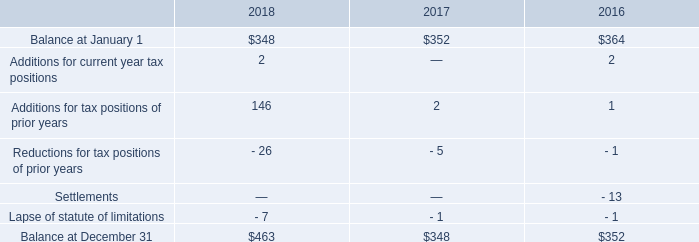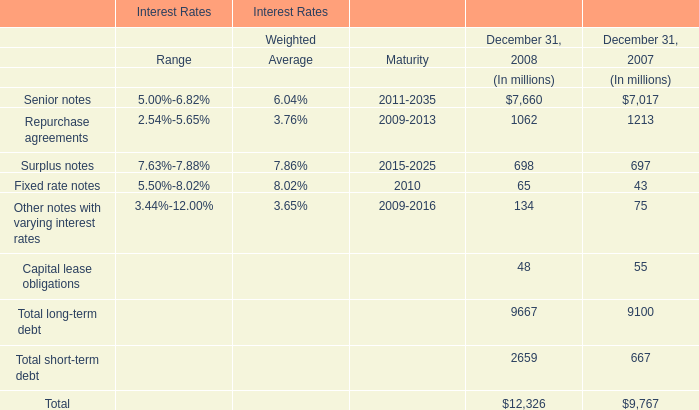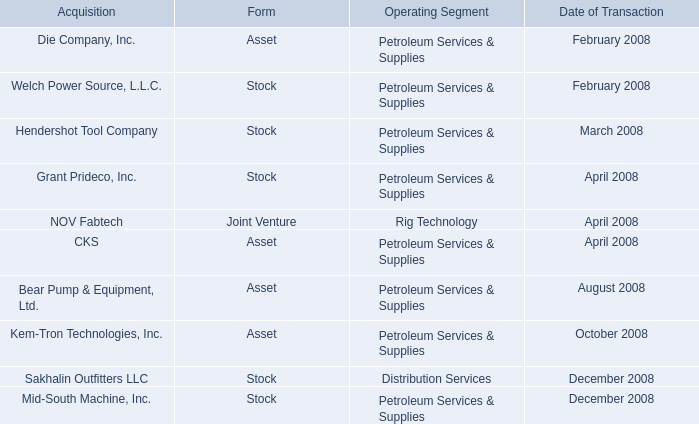Which year is Total short-term debt greater than 2000 million? 
Answer: 2008. 